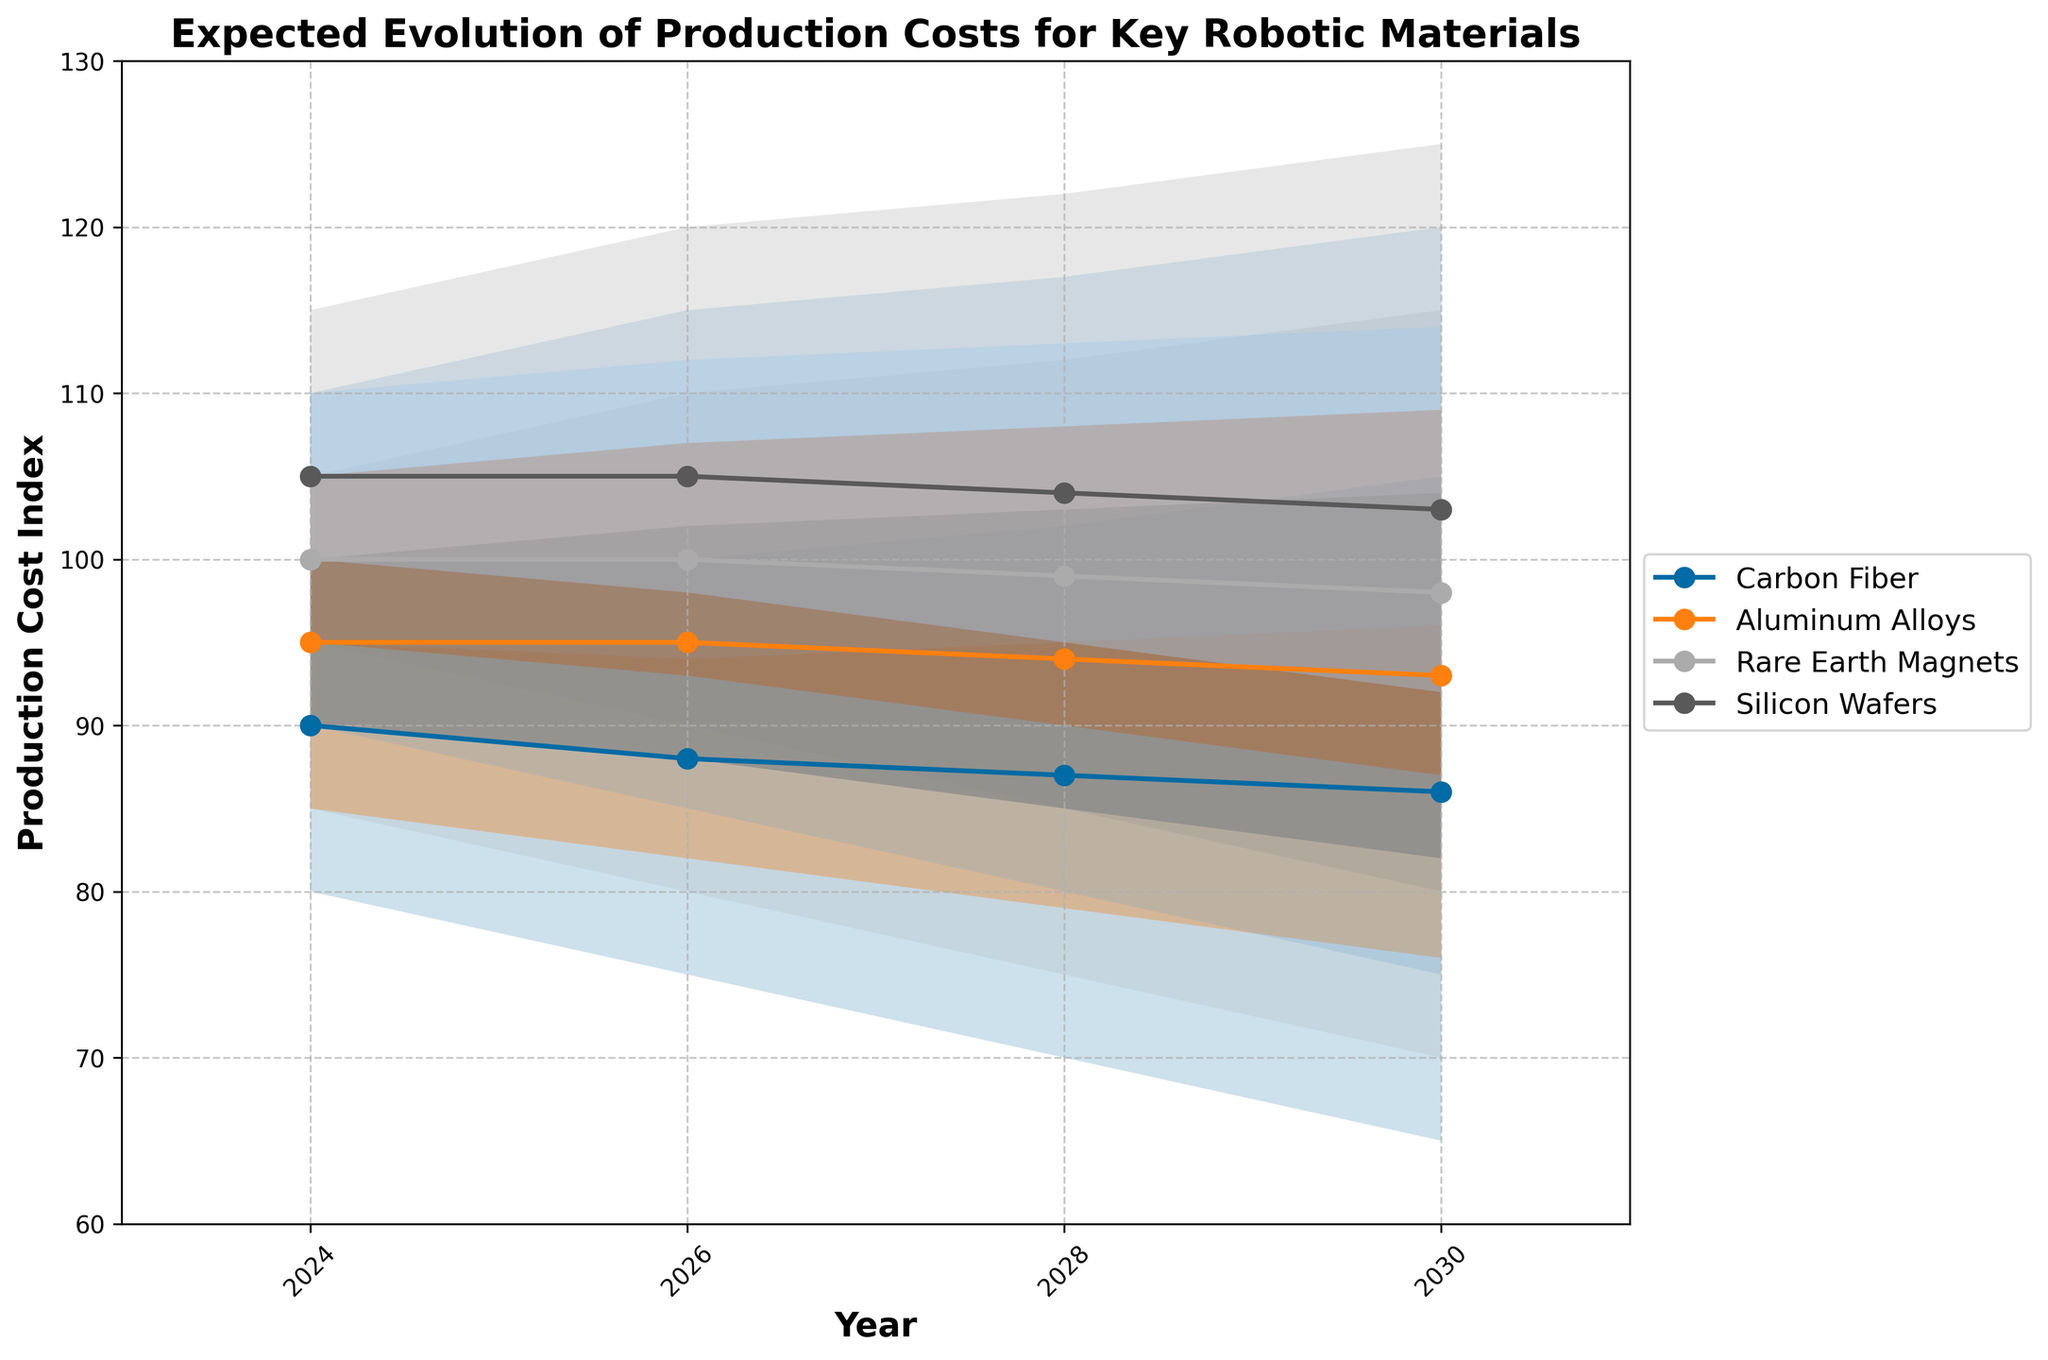What's the title of the figure? The title is displayed at the top of the figure, it reads "Expected Evolution of Production Costs for Key Robotic Materials".
Answer: Expected Evolution of Production Costs for Key Robotic Materials What is the projected mid-value production cost of Aluminum Alloys in 2028? The mid-value production cost for Aluminum Alloys in 2028 is shown on the line representing the mid-value for each material. For Aluminum Alloys, this value is 94.
Answer: 94 Which material shows the lowest mid-range production costs in 2030? By looking at the lowest mid-range value in 2030 across all materials, Carbon Fiber has the lowest at 86.
Answer: Carbon Fiber How does the range of uncertainty for Silicon Wafers from 2024 to 2030 change? From 2024 to 2030, the range of uncertainty for Silicon Wafers is given by the difference between the high and low values. It starts at (115 - 95 = 20) in 2024 and ends at (125 - 80 = 45) in 2030, showing an increase.
Answer: It increases Which material's production costs have the steepest decrease in mid-value from 2024 to 2030? By evaluating the mid-values of each material from 2024 to 2030, Carbon Fiber’s mid-value decreases from 90 to 86, which is the steepest change.
Answer: Carbon Fiber What is the average high production cost for Rare Earth Magnets across all years? The high production costs for Rare Earth Magnets over the years are: 110, 115, 117, 120. Sum these values and divide by the number of values: (110 + 115 + 117 + 120) / 4 = 115.5.
Answer: 115.5 By how much does the high value for Aluminum Alloys differ between 2024 and 2030? The high values for Aluminum Alloys in 2024 and 2030 are 105 and 115, respectively. The difference is calculated as 115 - 105 = 10.
Answer: 10 Which material has the smallest uncertainty range in 2026? In 2026, the uncertainty ranges (High - Low) for the materials are: Carbon Fiber (100 - 75 = 25), Aluminum Alloys (110 - 80 = 30), Rare Earth Magnets (115 - 85 = 30), Silicon Wafers (120 - 90 = 30). Therefore, Carbon Fiber has the smallest range.
Answer: Carbon Fiber 